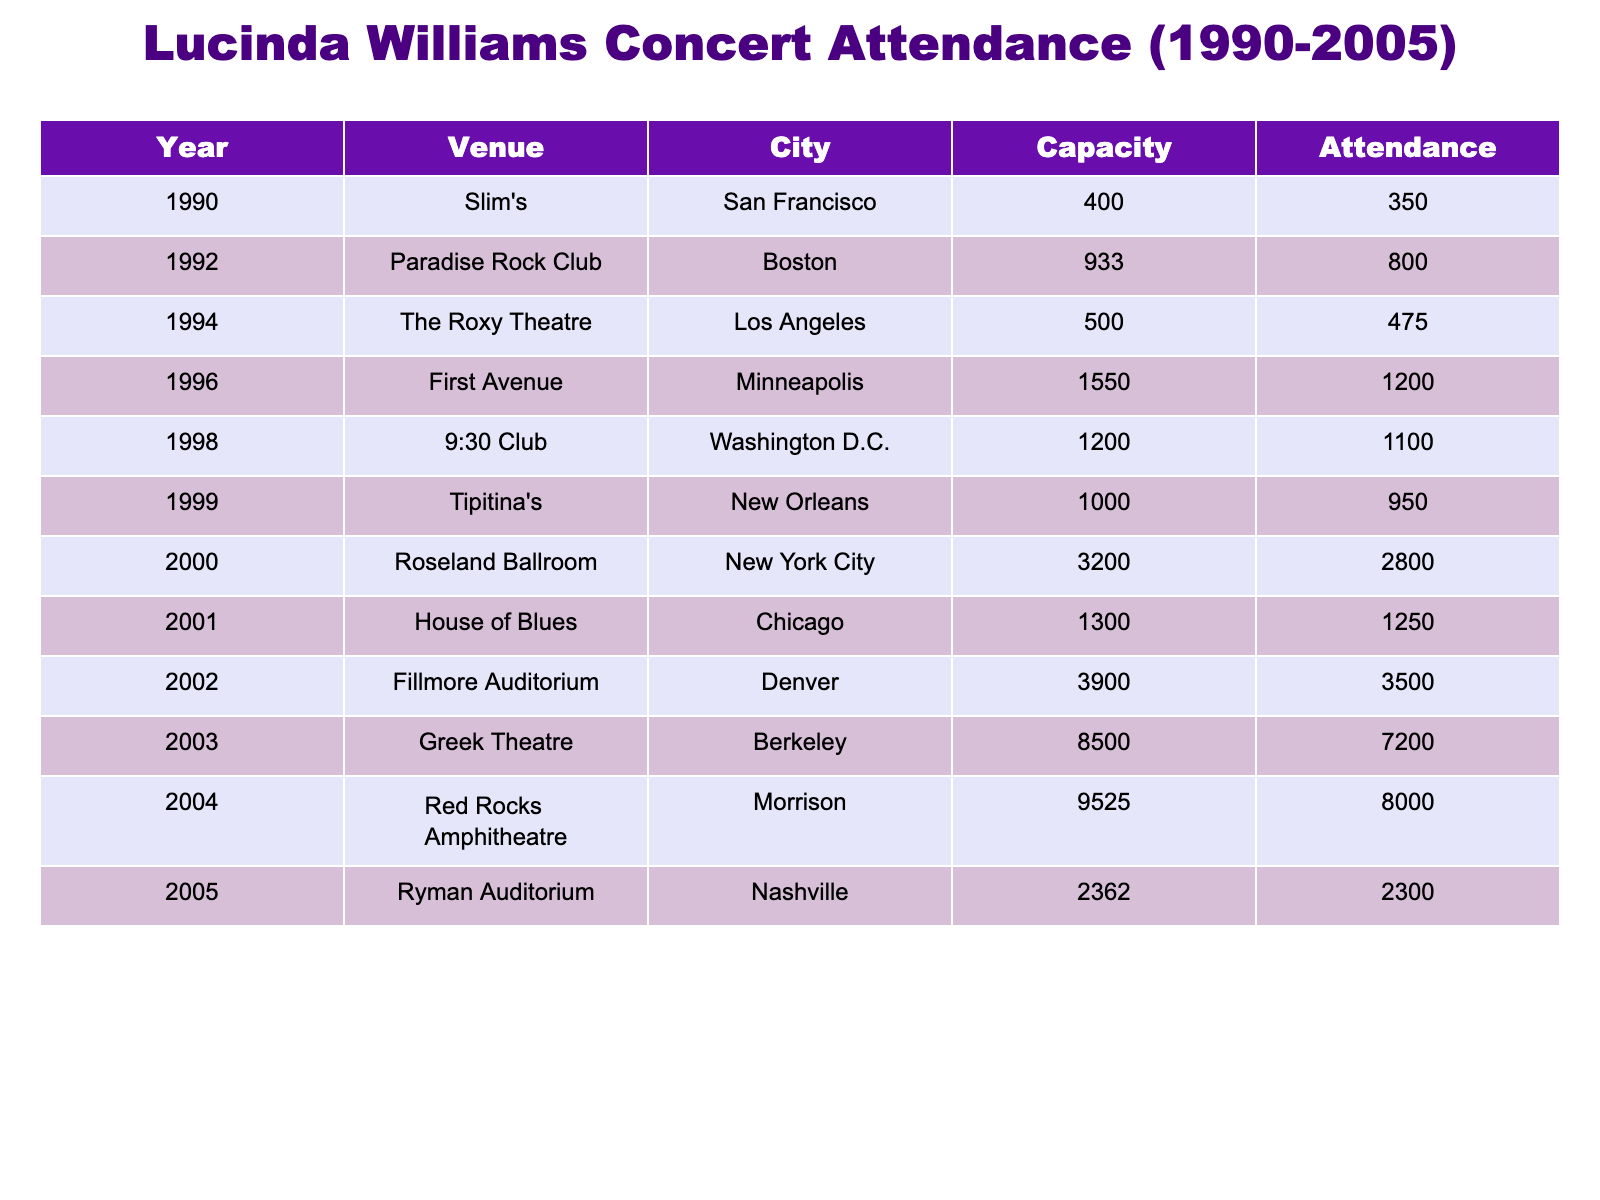What was the attendance at Roseland Ballroom in 2000? The table shows that in 2000, the attendance at Roseland Ballroom in New York City was 2800.
Answer: 2800 What city hosted the concert with the highest recorded capacity? The table indicates that Red Rocks Amphitheatre in Morrison had the highest capacity of 9525 in 2004.
Answer: Morrison What was the average attendance across all concerts in 2002? The table shows only one concert in 2002 at Fillmore Auditorium with an attendance of 3500, so the average attendance is 3500/1 = 3500.
Answer: 3500 What was the total attendance in the year 2003? In 2003, only one concert occurred at Greek Theatre, and it had an attendance of 7200. Therefore, total attendance for that year is 7200.
Answer: 7200 Did Lucinda Williams perform at a venue with a capacity of over 9000? The table shows that the only venue with a capacity over 9000 is Red Rocks Amphitheatre in 2004, where she performed. Thus, the answer is yes.
Answer: Yes What was the difference in attendance between the smallest and largest venues? The smallest venue was Slim's in 1990 with 350 attendees, and the largest was Greek Theatre in 2003 with 7200 attendees. The difference in attendance is 7200 - 350 = 6850.
Answer: 6850 Which city had the lowest attendance at a concert during this period? The lowest attendance recorded was at Slim's in San Francisco in 1990 with 350 attendees.
Answer: San Francisco What was the median capacity of the venues where Lucinda performed? The capacities listed are 400, 933, 500, 1550, 1200, 1000, 3200, 1300, 3900, 9525, and 2362. When arranged in order, the median, the middle value is 1550.
Answer: 1550 How many venues had an attendance greater than 2000? From the table, the venues with attendance greater than 2000 are Roseland Ballroom (2800), Fillmore Auditorium (3500), Greek Theatre (7200), Red Rocks Amphitheatre (8000), and Ryman Auditorium (2300). This is a total of 5 venues.
Answer: 5 What percentage of capacity was filled at First Avenue in 1996? The capacity for First Avenue was 1550 and the attendance was 1200. To calculate the percentage filled: (1200/1550) * 100 = 77.42%.
Answer: 77.42% 